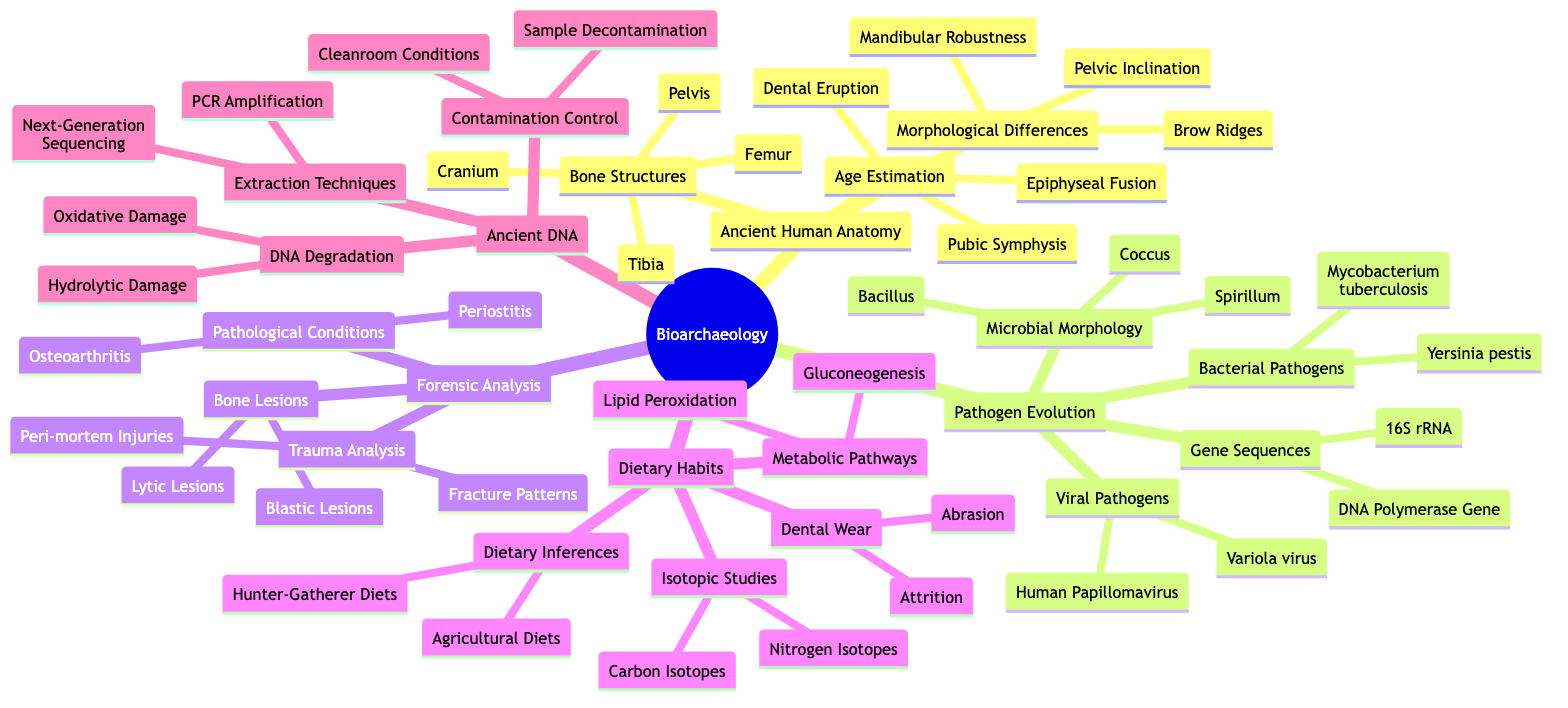What are the three main categories under Ancient Human Anatomy? The diagram lists three main categories under Ancient Human Anatomy: Bone Structures, Age Estimation, and Morphological Differences. This information can be directly found in the first level of the mindmap.
Answer: Bone Structures, Age Estimation, Morphological Differences How many types of pathogens are identified in the Pathogen Evolution section? In the Pathogen Evolution section, there are two types of pathogens mentioned: Bacterial Pathogens and Viral Pathogens. This can be derived from the branches under the main category of Pathogen Evolution.
Answer: 2 What bone structure is specifically highlighted in the Forensic Analysis category? The Forensic Analysis category includes a specific focus on Trauma Analysis which lists fracture patterns and peri-mortem injuries, but no one bone structure is explicitly named here. However, the right answer would be inferred as 'Fracture Patterns', as they relate directly to bone structure investigations.
Answer: Fracture Patterns Which isotopes are used in the Dietary Habits section for isotopic studies? The Dietary Habits section indicates that Carbon Isotopes and Nitrogen Isotopes are used in isotopic studies. This is listed explicitly in the mindmap under the Isotopic Studies category, making it clear and direct.
Answer: Carbon Isotopes, Nitrogen Isotopes What extraction techniques are involved in reconstructing ancient DNA? For reconstructing ancient DNA, the diagram specifies that PCR Amplification and Next-Generation Sequencing are the extraction techniques. This information is visually presented under the Ancient DNA section.
Answer: PCR Amplification, Next-Generation Sequencing What are the two types of morphological differences listed in the Ancient Human Anatomy section? In the Ancient Human Anatomy section, two types of morphological differences mentioned are Brow Ridges and Mandibular Robustness, as these are explicitly listed under the Morphological Differences category.
Answer: Brow Ridges, Mandibular Robustness Which pathogen is specifically identified under Bacterial Pathogens? The Bacterial Pathogens category includes two specific pathogens, one of which is Yersinia pestis, explicitly listed in the diagram as a focus area.
Answer: Yersinia pestis What kind of injuries are analyzed in Forensic Bioarchaeology and what are they referred to? The Forensic Bioarchaeology section involves analyzing trauma with a focus on Peri-mortem Injuries, which are specifically named in relation to trauma analysis, and indicate injuries occurring around the time of death.
Answer: Peri-mortem Injuries 